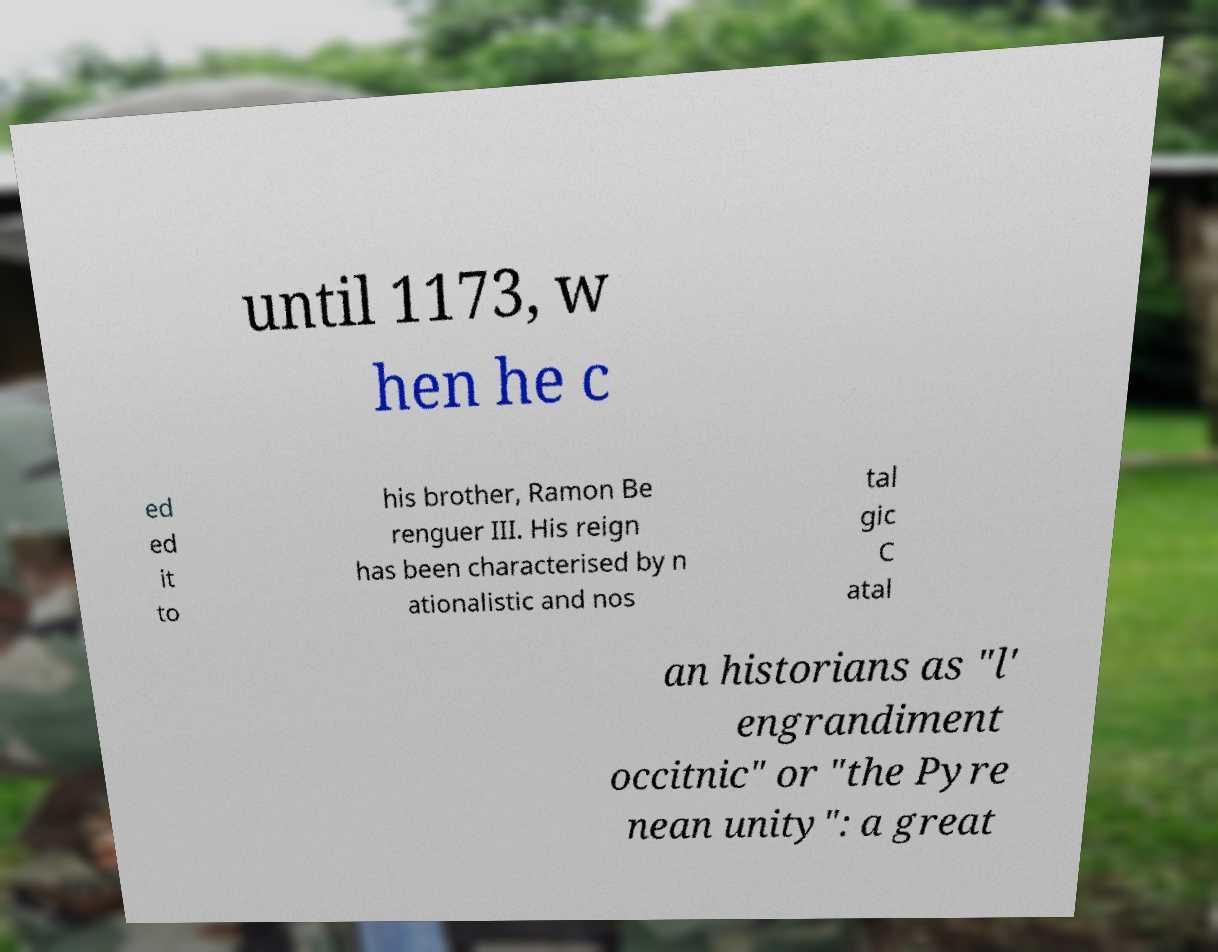For documentation purposes, I need the text within this image transcribed. Could you provide that? until 1173, w hen he c ed ed it to his brother, Ramon Be renguer III. His reign has been characterised by n ationalistic and nos tal gic C atal an historians as "l' engrandiment occitnic" or "the Pyre nean unity": a great 